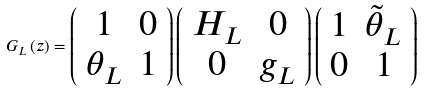Convert formula to latex. <formula><loc_0><loc_0><loc_500><loc_500>G _ { L } \left ( z \right ) = \left ( \begin{array} { c c } 1 & 0 \\ \theta _ { L } & 1 \end{array} \right ) \left ( \begin{array} { c c } H _ { L } & 0 \\ 0 & g _ { L } \end{array} \right ) \left ( \begin{array} { c c } 1 & \tilde { \theta } _ { L } \\ 0 & 1 \end{array} \right )</formula> 